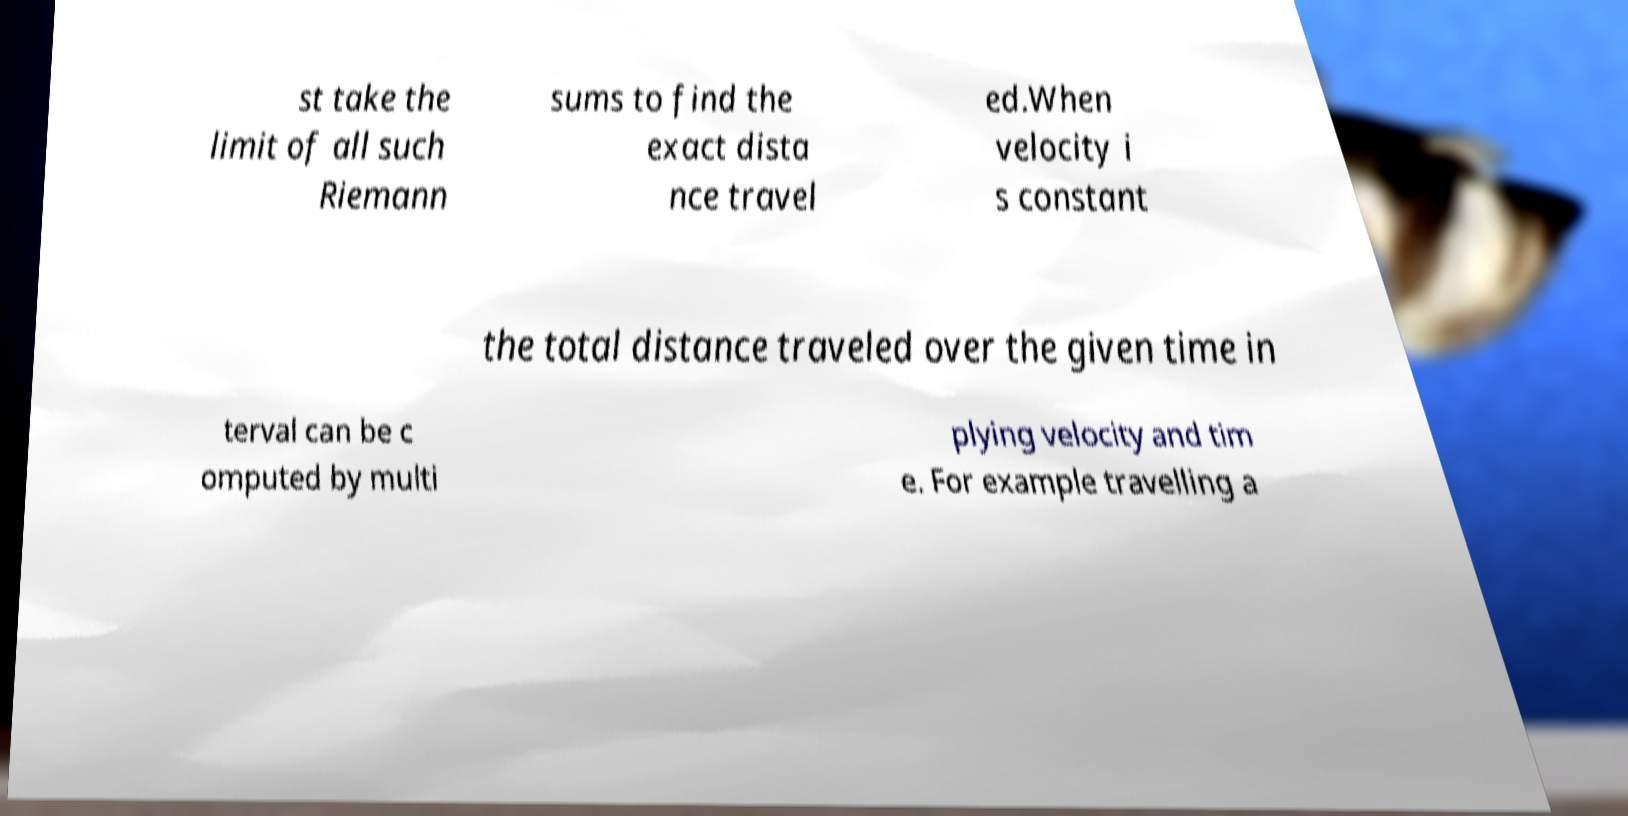There's text embedded in this image that I need extracted. Can you transcribe it verbatim? st take the limit of all such Riemann sums to find the exact dista nce travel ed.When velocity i s constant the total distance traveled over the given time in terval can be c omputed by multi plying velocity and tim e. For example travelling a 